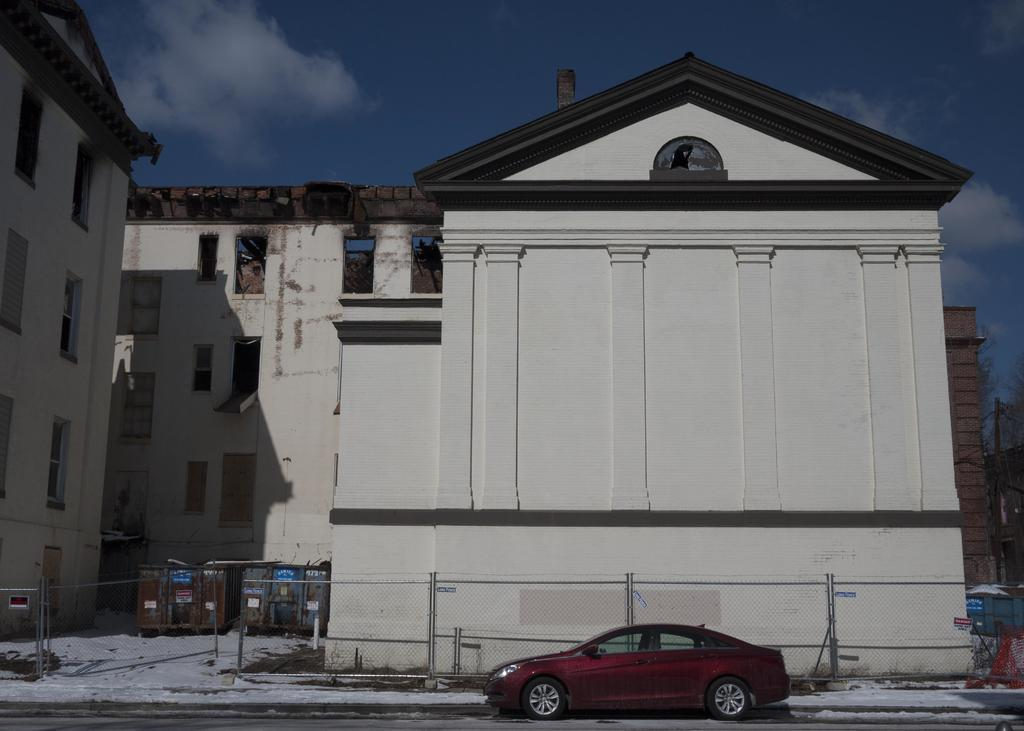What is on the road in the image? There is a vehicle on the road in the image. What can be seen beside the road? There is a fence beside the road in the image, and there are some objects visible as well. What structures can be seen in the image? There are buildings visible in the image. What is visible in the background of the image? The sky is visible in the background of the image, and clouds are present in the sky. What type of curtain is hanging in the vehicle in the image? There is no curtain present in the vehicle in the image; it is a vehicle on the road. 